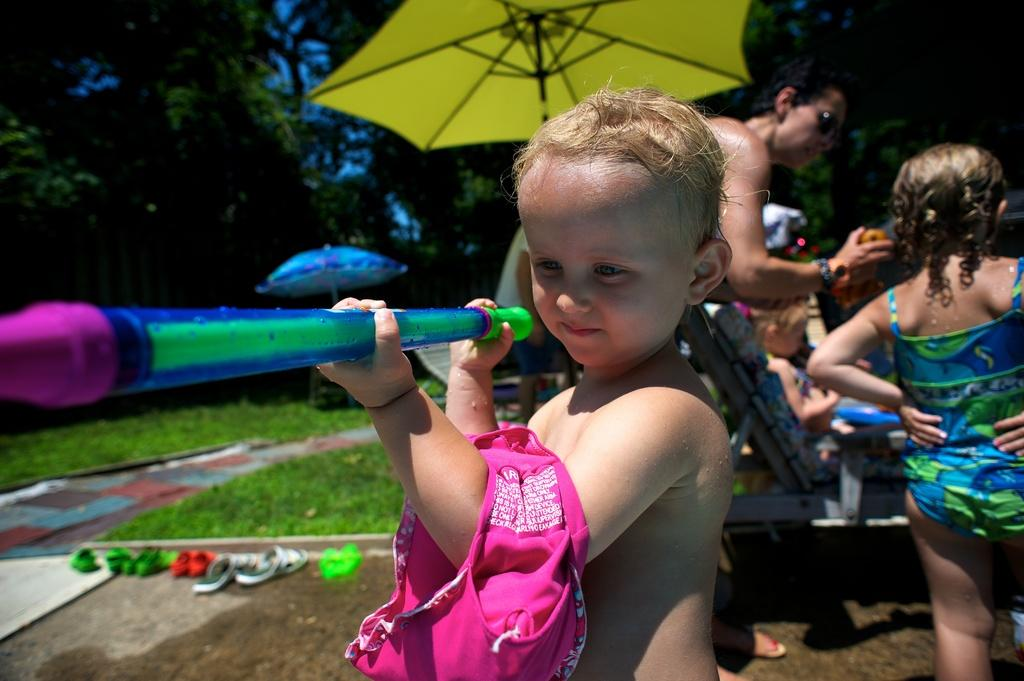What is the main subject in the foreground of the image? There is a child playing in the foreground of the image. Can you describe any other people visible in the image? Yes, there are other people visible in the image. What type of natural elements can be seen in the image? There are trees in the image. What type of infrastructure is present in the image? Sleepers (railway ties) are present in the image. What type of wine is being served at the picnic in the image? There is no picnic or wine present in the image; it features a child playing and other people in the background. How many bushes are visible in the image? There is no mention of bushes in the provided facts, so we cannot determine the number of bushes in the image. 